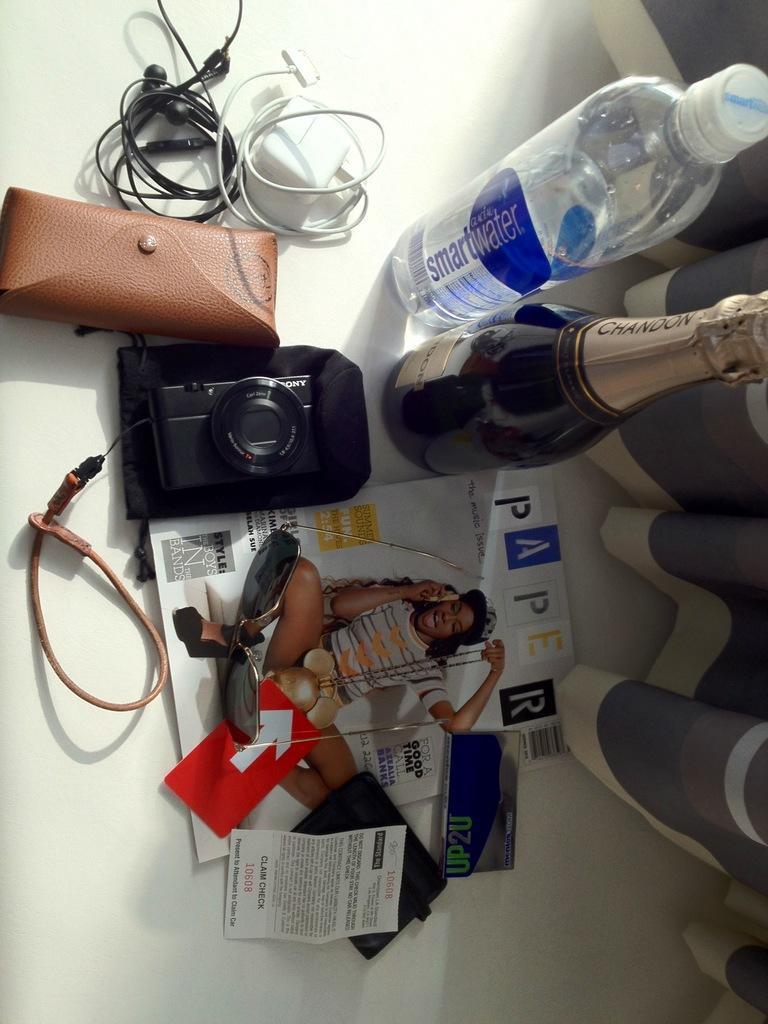Please provide a concise description of this image. In this image there are two bottles and one charger white in colour one headphone black in colour one spectacle case brown in colour one camera and there is one magazine on the magazine there is one google. In the background one curtain which is grey in colour is visible. 